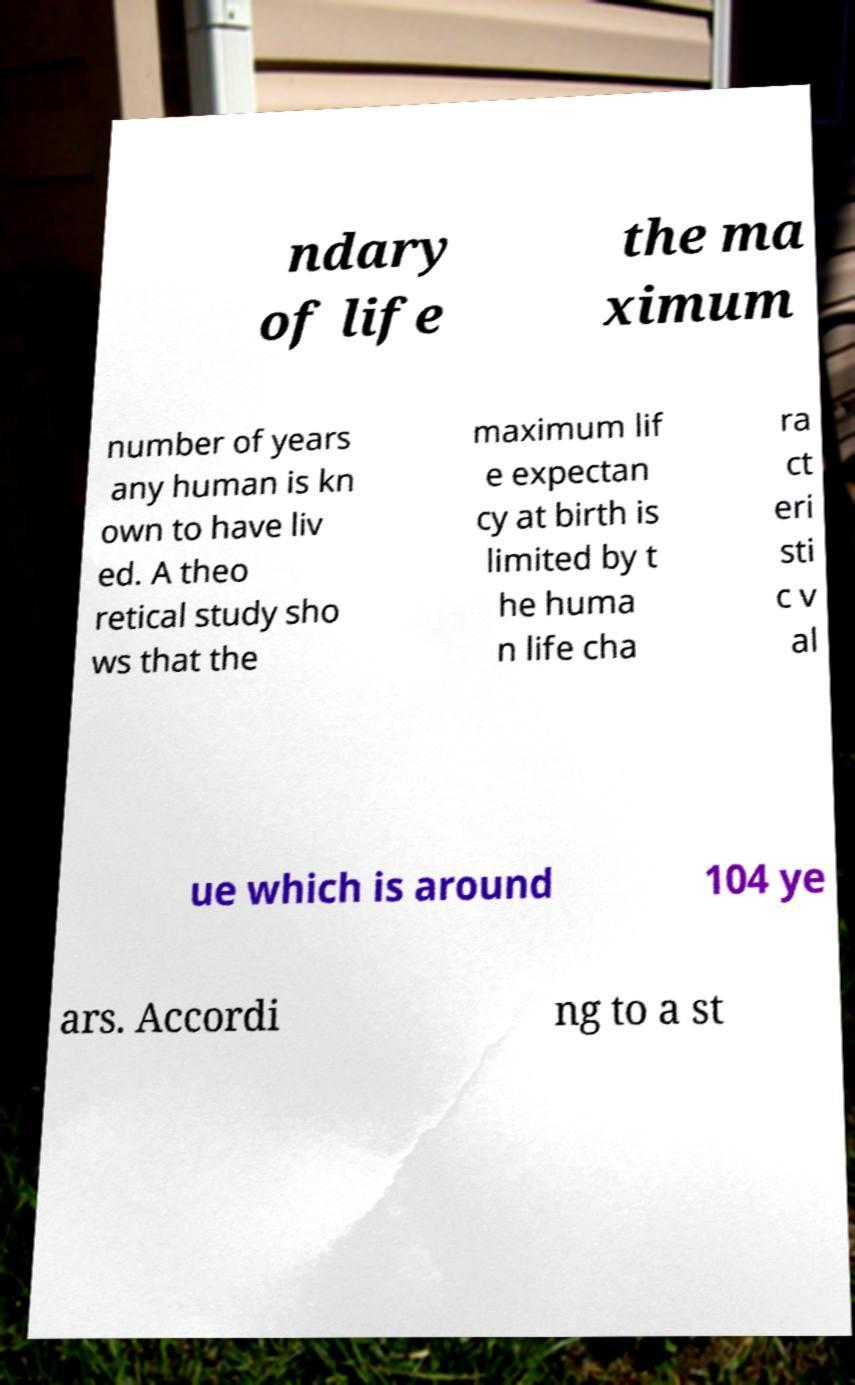Could you assist in decoding the text presented in this image and type it out clearly? ndary of life the ma ximum number of years any human is kn own to have liv ed. A theo retical study sho ws that the maximum lif e expectan cy at birth is limited by t he huma n life cha ra ct eri sti c v al ue which is around 104 ye ars. Accordi ng to a st 